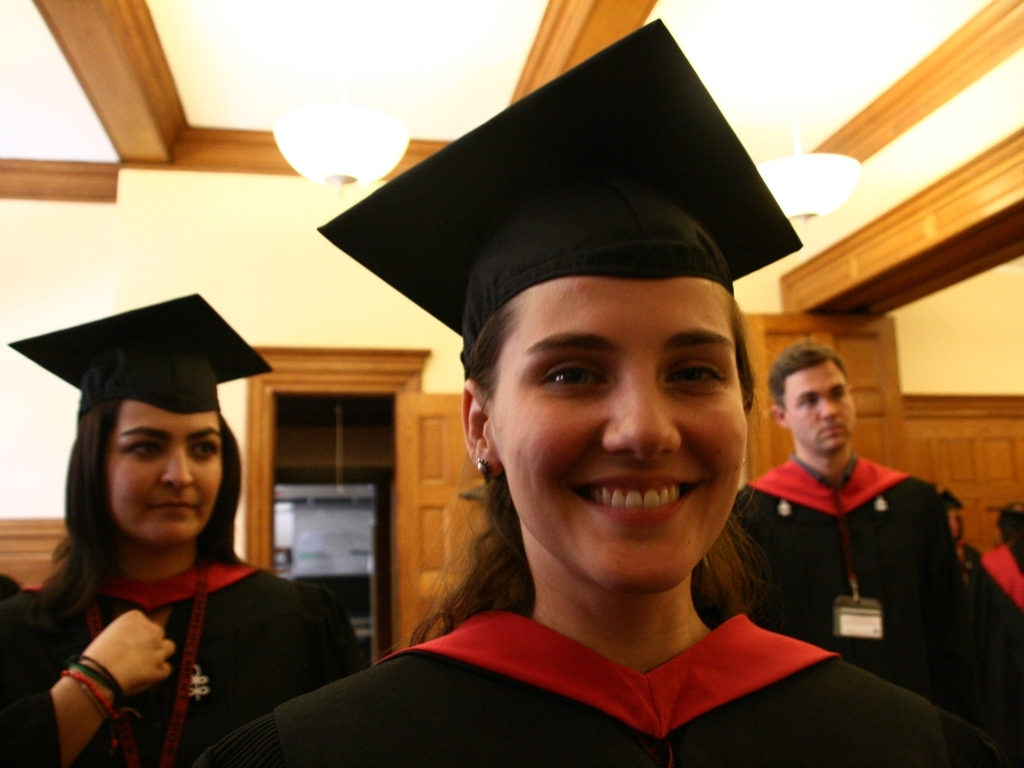Is the blurring of the two people in the background too severe? The blurring of the two individuals in the background is noticeable and does impact the clarity of the image. However, the extent to which it is 'too severe' can be subjective and depends on the intention behind the photograph. If the goal was to emphasize the person in the foreground and capture their moment, such as a graduation portrait, then the background blur helps to isolate them and draw attention to their smile and graduation attire. On the other hand, if the image was expected to include a clear view of all individuals, the blur could be considered excessive. 